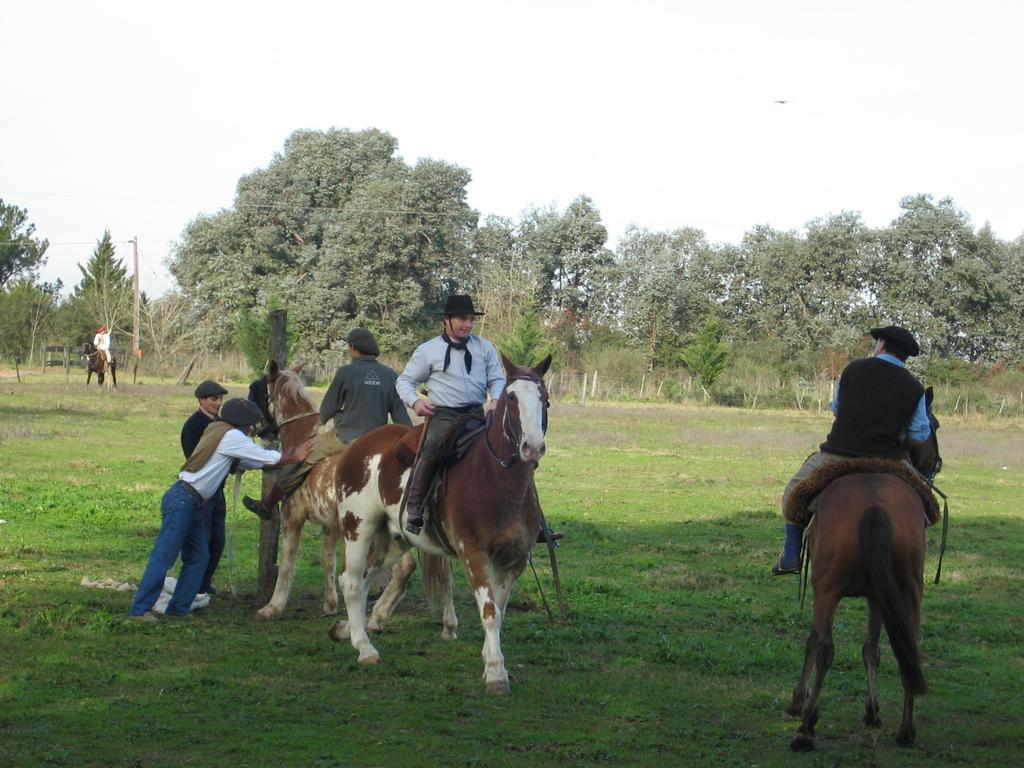How many men are sitting on a horse in the image? There are three men sitting on a horse in the image. What are the positions of the other men in the image? Two men are standing to the left side, and there is a man sitting on a horse in the background. What type of door can be seen in the image? There is no door present in the image. What medical advice can the doctor provide in the image? There is no doctor present in the image. 